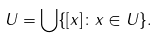<formula> <loc_0><loc_0><loc_500><loc_500>U = \bigcup \{ [ x ] \colon x \in U \} .</formula> 